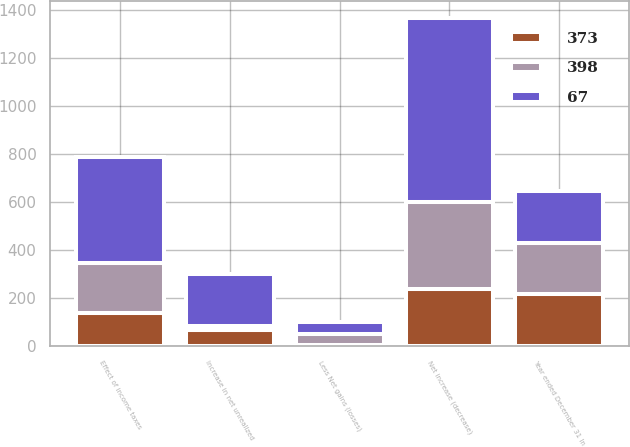Convert chart. <chart><loc_0><loc_0><loc_500><loc_500><stacked_bar_chart><ecel><fcel>Year ended December 31 In<fcel>Increase in net unrealized<fcel>Less Net gains (losses)<fcel>Net increase (decrease)<fcel>Effect of income taxes<nl><fcel>398<fcel>215<fcel>17<fcel>48<fcel>361<fcel>208<nl><fcel>373<fcel>215<fcel>68<fcel>4<fcel>238<fcel>137<nl><fcel>67<fcel>215<fcel>215<fcel>50<fcel>768<fcel>443<nl></chart> 